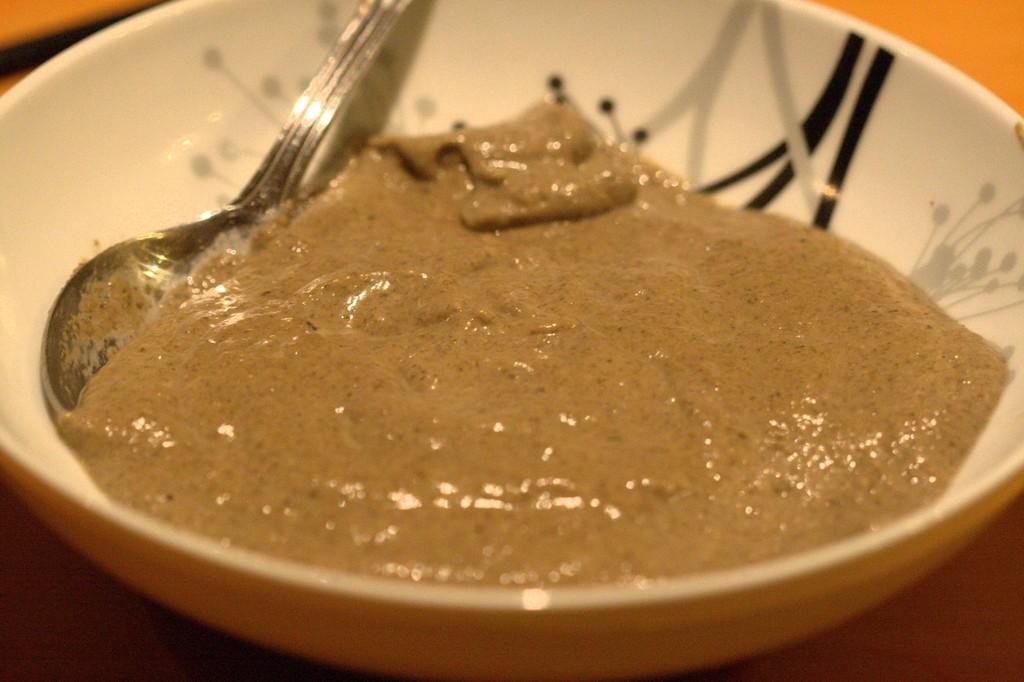What is in the bowl that is visible in the image? There is a bowl containing food in the image. What utensil is present in the bowl? There is a spoon in the bowl. Where is the bowl located? The bowl is placed on a table. How many cows are visible in the image? There are no cows present in the image. 